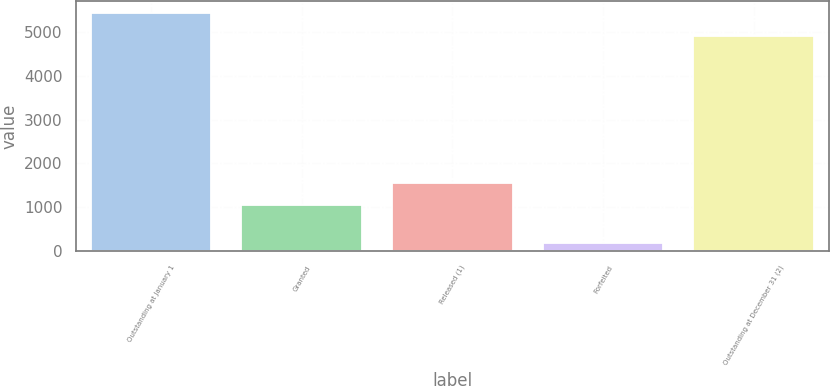<chart> <loc_0><loc_0><loc_500><loc_500><bar_chart><fcel>Outstanding at January 1<fcel>Granted<fcel>Released (1)<fcel>Forfeited<fcel>Outstanding at December 31 (2)<nl><fcel>5427.5<fcel>1044<fcel>1563.5<fcel>199<fcel>4908<nl></chart> 